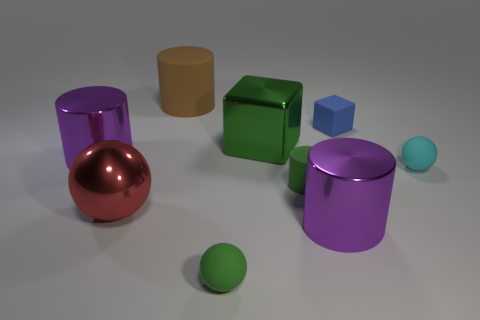There is a blue matte thing; what shape is it?
Your answer should be very brief. Cube. How many other small matte cylinders are the same color as the tiny cylinder?
Offer a very short reply. 0. The big shiny object that is the same shape as the tiny blue matte object is what color?
Give a very brief answer. Green. How many matte cylinders are right of the matte sphere in front of the big red metallic ball?
Provide a succinct answer. 1. How many cylinders are either red matte things or tiny blue things?
Provide a succinct answer. 0. Are any big purple cylinders visible?
Provide a short and direct response. Yes. There is a metallic thing that is the same shape as the blue rubber thing; what size is it?
Provide a short and direct response. Large. There is a purple object on the right side of the small sphere in front of the cyan matte thing; what shape is it?
Ensure brevity in your answer.  Cylinder. How many green things are matte cylinders or small rubber spheres?
Offer a very short reply. 2. What is the color of the large sphere?
Offer a terse response. Red. 